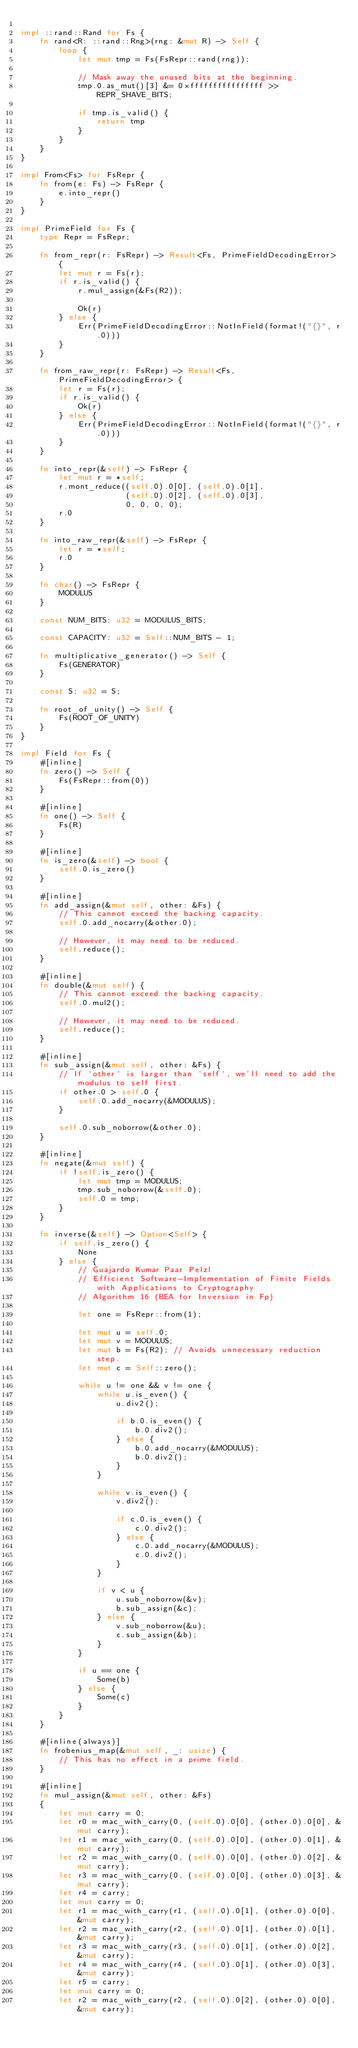<code> <loc_0><loc_0><loc_500><loc_500><_Rust_>
impl ::rand::Rand for Fs {
    fn rand<R: ::rand::Rng>(rng: &mut R) -> Self {
        loop {
            let mut tmp = Fs(FsRepr::rand(rng));

            // Mask away the unused bits at the beginning.
            tmp.0.as_mut()[3] &= 0xffffffffffffffff >> REPR_SHAVE_BITS;

            if tmp.is_valid() {
                return tmp
            }
        }
    }
}

impl From<Fs> for FsRepr {
    fn from(e: Fs) -> FsRepr {
        e.into_repr()
    }
}

impl PrimeField for Fs {
    type Repr = FsRepr;

    fn from_repr(r: FsRepr) -> Result<Fs, PrimeFieldDecodingError> {
        let mut r = Fs(r);
        if r.is_valid() {
            r.mul_assign(&Fs(R2));

            Ok(r)
        } else {
            Err(PrimeFieldDecodingError::NotInField(format!("{}", r.0)))
        }
    }

    fn from_raw_repr(r: FsRepr) -> Result<Fs, PrimeFieldDecodingError> {
        let r = Fs(r);
        if r.is_valid() {
            Ok(r)
        } else {
            Err(PrimeFieldDecodingError::NotInField(format!("{}", r.0)))
        }
    }

    fn into_repr(&self) -> FsRepr {
        let mut r = *self;
        r.mont_reduce((self.0).0[0], (self.0).0[1],
                      (self.0).0[2], (self.0).0[3],
                      0, 0, 0, 0);
        r.0
    }

    fn into_raw_repr(&self) -> FsRepr {
        let r = *self;
        r.0
    }

    fn char() -> FsRepr {
        MODULUS
    }

    const NUM_BITS: u32 = MODULUS_BITS;

    const CAPACITY: u32 = Self::NUM_BITS - 1;

    fn multiplicative_generator() -> Self {
        Fs(GENERATOR)
    }

    const S: u32 = S;

    fn root_of_unity() -> Self {
        Fs(ROOT_OF_UNITY)
    }
}

impl Field for Fs {
    #[inline]
    fn zero() -> Self {
        Fs(FsRepr::from(0))
    }

    #[inline]
    fn one() -> Self {
        Fs(R)
    }

    #[inline]
    fn is_zero(&self) -> bool {
        self.0.is_zero()
    }

    #[inline]
    fn add_assign(&mut self, other: &Fs) {
        // This cannot exceed the backing capacity.
        self.0.add_nocarry(&other.0);

        // However, it may need to be reduced.
        self.reduce();
    }

    #[inline]
    fn double(&mut self) {
        // This cannot exceed the backing capacity.
        self.0.mul2();

        // However, it may need to be reduced.
        self.reduce();
    }

    #[inline]
    fn sub_assign(&mut self, other: &Fs) {
        // If `other` is larger than `self`, we'll need to add the modulus to self first.
        if other.0 > self.0 {
            self.0.add_nocarry(&MODULUS);
        }

        self.0.sub_noborrow(&other.0);
    }

    #[inline]
    fn negate(&mut self) {
        if !self.is_zero() {
            let mut tmp = MODULUS;
            tmp.sub_noborrow(&self.0);
            self.0 = tmp;
        }
    }

    fn inverse(&self) -> Option<Self> {
        if self.is_zero() {
            None
        } else {
            // Guajardo Kumar Paar Pelzl
            // Efficient Software-Implementation of Finite Fields with Applications to Cryptography
            // Algorithm 16 (BEA for Inversion in Fp)

            let one = FsRepr::from(1);

            let mut u = self.0;
            let mut v = MODULUS;
            let mut b = Fs(R2); // Avoids unnecessary reduction step.
            let mut c = Self::zero();

            while u != one && v != one {
                while u.is_even() {
                    u.div2();

                    if b.0.is_even() {
                        b.0.div2();
                    } else {
                        b.0.add_nocarry(&MODULUS);
                        b.0.div2();
                    }
                }

                while v.is_even() {
                    v.div2();

                    if c.0.is_even() {
                        c.0.div2();
                    } else {
                        c.0.add_nocarry(&MODULUS);
                        c.0.div2();
                    }
                }

                if v < u {
                    u.sub_noborrow(&v);
                    b.sub_assign(&c);
                } else {
                    v.sub_noborrow(&u);
                    c.sub_assign(&b);
                }
            }

            if u == one {
                Some(b)
            } else {
                Some(c)
            }
        }
    }

    #[inline(always)]
    fn frobenius_map(&mut self, _: usize) {
        // This has no effect in a prime field.
    }

    #[inline]
    fn mul_assign(&mut self, other: &Fs)
    {
        let mut carry = 0;
        let r0 = mac_with_carry(0, (self.0).0[0], (other.0).0[0], &mut carry);
        let r1 = mac_with_carry(0, (self.0).0[0], (other.0).0[1], &mut carry);
        let r2 = mac_with_carry(0, (self.0).0[0], (other.0).0[2], &mut carry);
        let r3 = mac_with_carry(0, (self.0).0[0], (other.0).0[3], &mut carry);
        let r4 = carry;
        let mut carry = 0;
        let r1 = mac_with_carry(r1, (self.0).0[1], (other.0).0[0], &mut carry);
        let r2 = mac_with_carry(r2, (self.0).0[1], (other.0).0[1], &mut carry);
        let r3 = mac_with_carry(r3, (self.0).0[1], (other.0).0[2], &mut carry);
        let r4 = mac_with_carry(r4, (self.0).0[1], (other.0).0[3], &mut carry);
        let r5 = carry;
        let mut carry = 0;
        let r2 = mac_with_carry(r2, (self.0).0[2], (other.0).0[0], &mut carry);</code> 